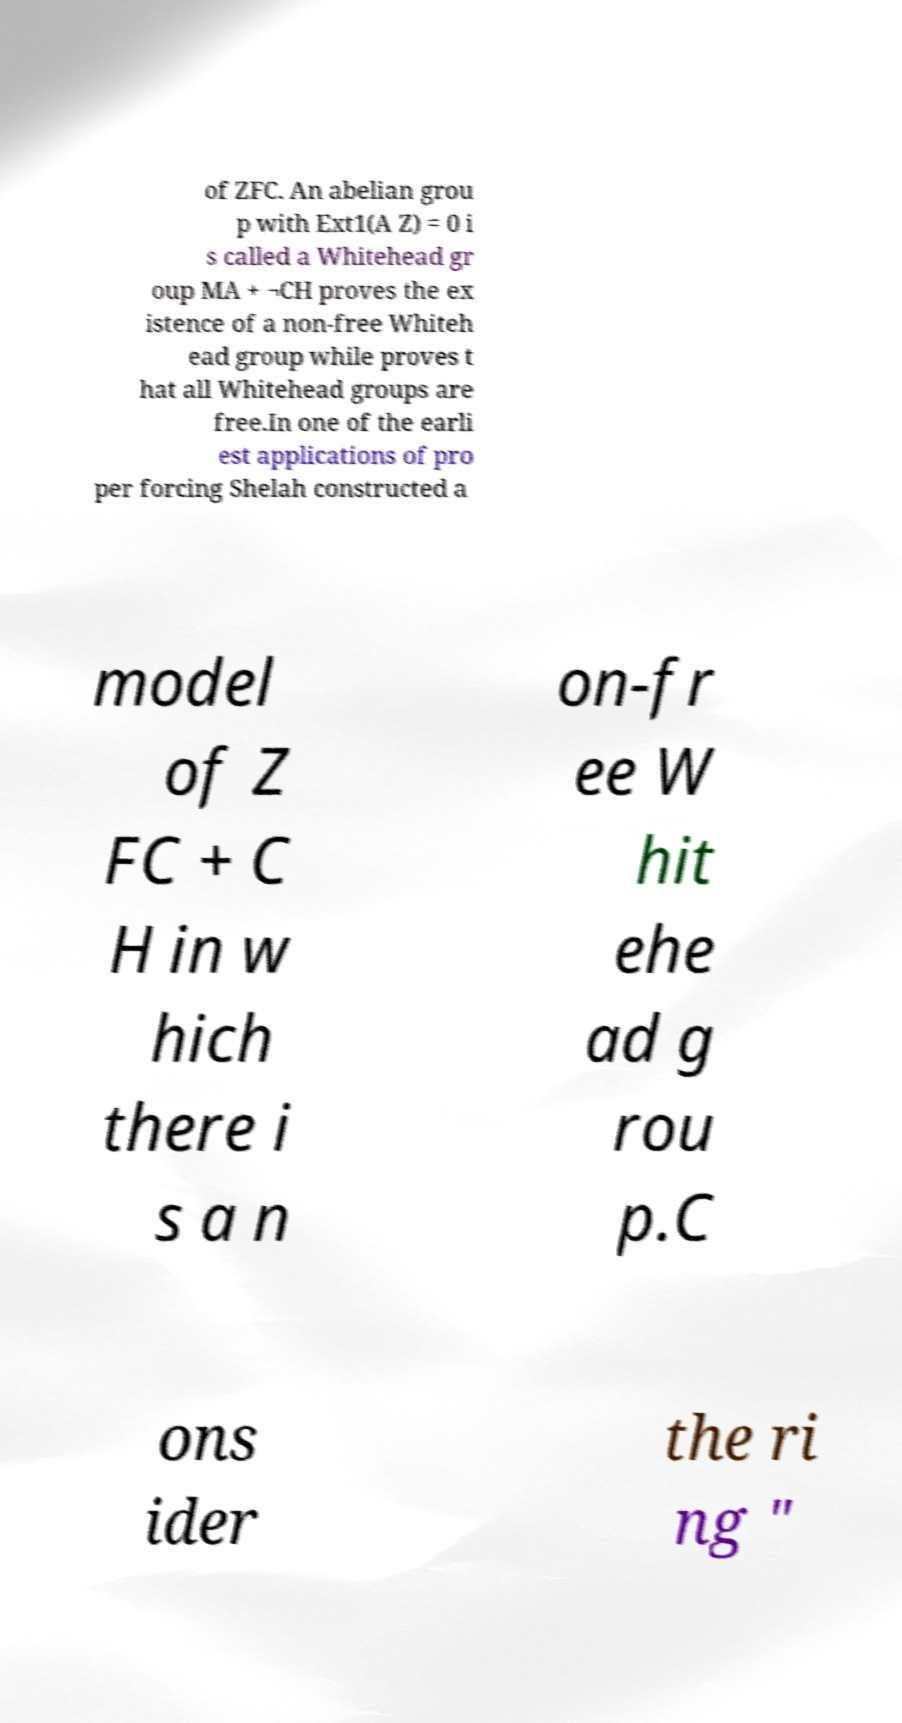Could you assist in decoding the text presented in this image and type it out clearly? of ZFC. An abelian grou p with Ext1(A Z) = 0 i s called a Whitehead gr oup MA + ¬CH proves the ex istence of a non-free Whiteh ead group while proves t hat all Whitehead groups are free.In one of the earli est applications of pro per forcing Shelah constructed a model of Z FC + C H in w hich there i s a n on-fr ee W hit ehe ad g rou p.C ons ider the ri ng " 